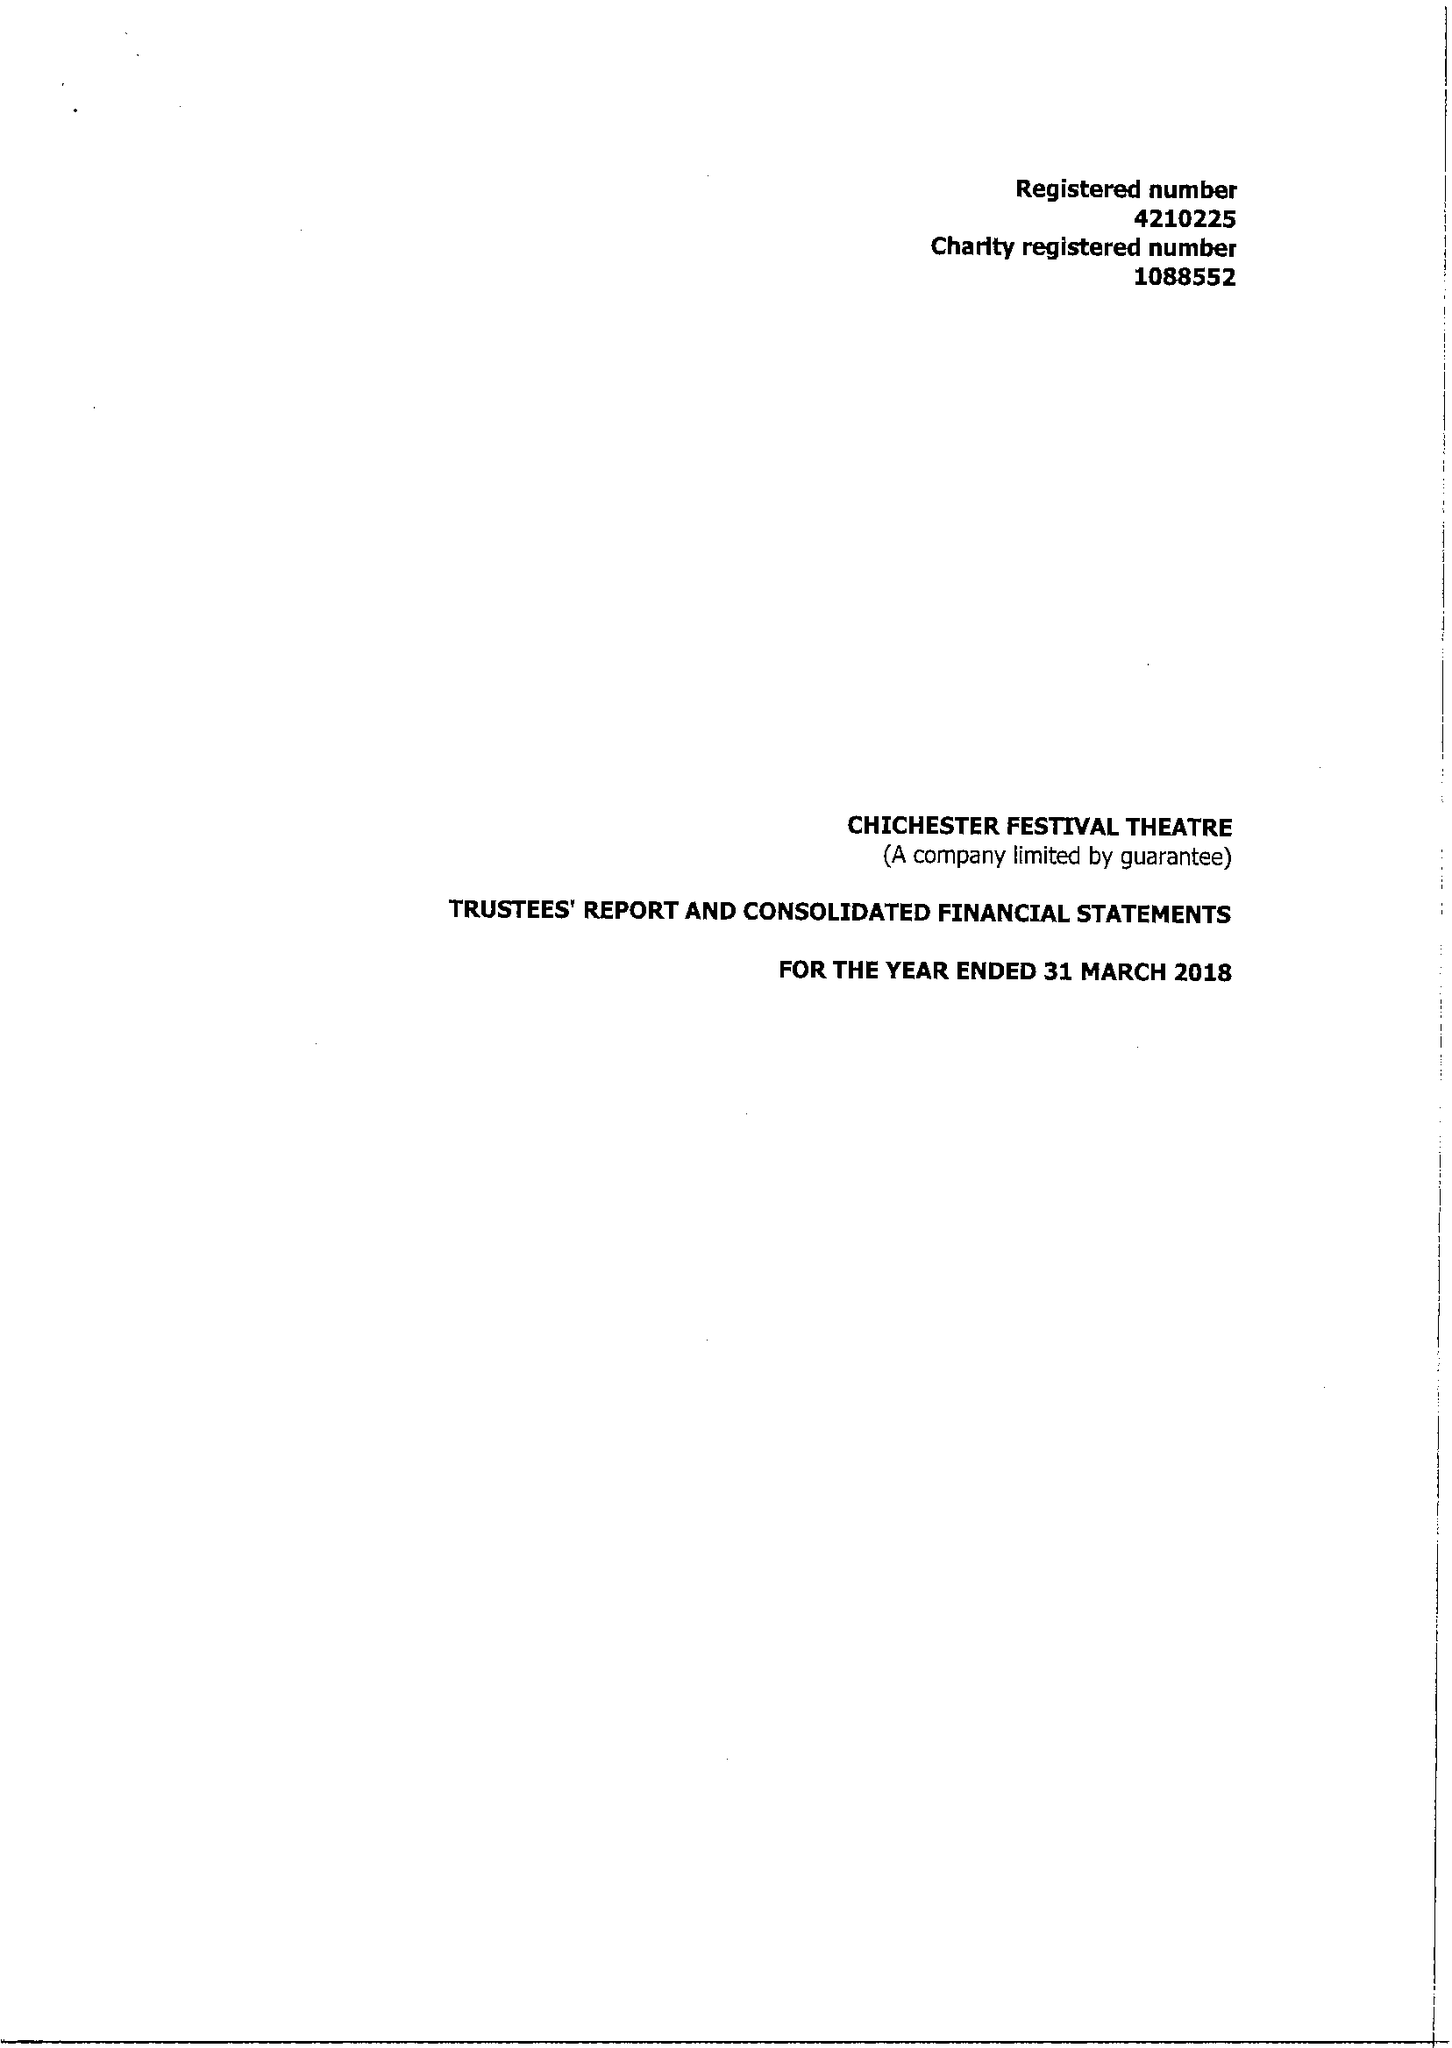What is the value for the spending_annually_in_british_pounds?
Answer the question using a single word or phrase. 14966179.00 